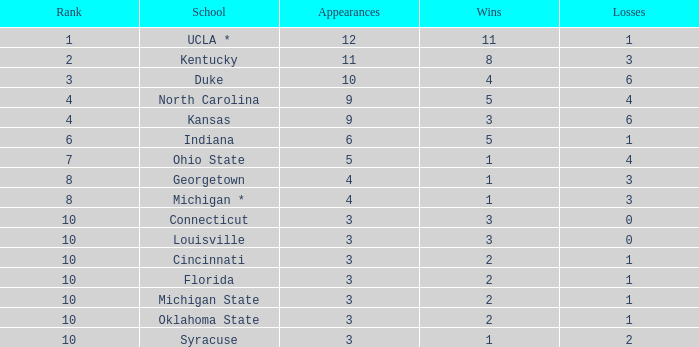Parse the table in full. {'header': ['Rank', 'School', 'Appearances', 'Wins', 'Losses'], 'rows': [['1', 'UCLA *', '12', '11', '1'], ['2', 'Kentucky', '11', '8', '3'], ['3', 'Duke', '10', '4', '6'], ['4', 'North Carolina', '9', '5', '4'], ['4', 'Kansas', '9', '3', '6'], ['6', 'Indiana', '6', '5', '1'], ['7', 'Ohio State', '5', '1', '4'], ['8', 'Georgetown', '4', '1', '3'], ['8', 'Michigan *', '4', '1', '3'], ['10', 'Connecticut', '3', '3', '0'], ['10', 'Louisville', '3', '3', '0'], ['10', 'Cincinnati', '3', '2', '1'], ['10', 'Florida', '3', '2', '1'], ['10', 'Michigan State', '3', '2', '1'], ['10', 'Oklahoma State', '3', '2', '1'], ['10', 'Syracuse', '3', '1', '2']]} Tell me the sum of losses for wins less than 2 and rank of 10 with appearances larger than 3 None. 